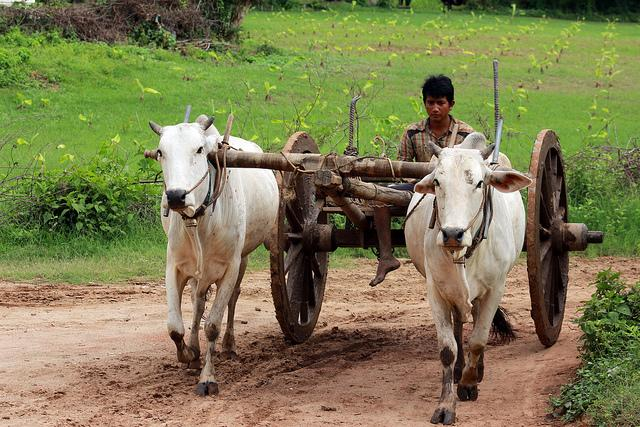What is behind the animals? Please explain your reasoning. wheels. There are some big wooden wheels pulled behind the animals. 